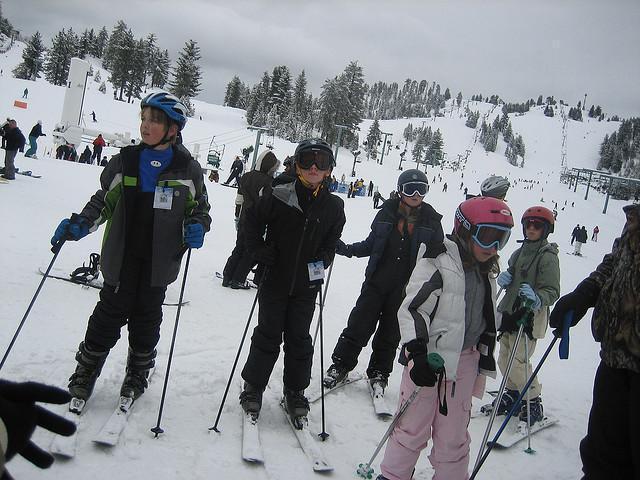How many people are wearing glasses?
Give a very brief answer. 4. How many people are looking at the camera?
Give a very brief answer. 1. How many kids wearing sunglasses?
Give a very brief answer. 4. How many people are in the photo?
Give a very brief answer. 6. 